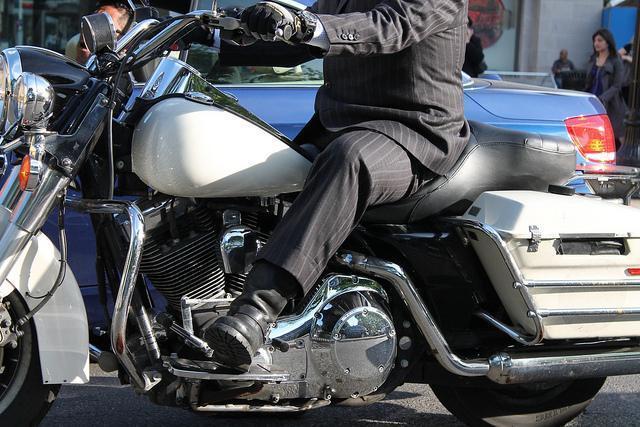How many seats are on this bike?
Give a very brief answer. 1. How many cars are there?
Give a very brief answer. 1. How many people can you see?
Give a very brief answer. 2. 